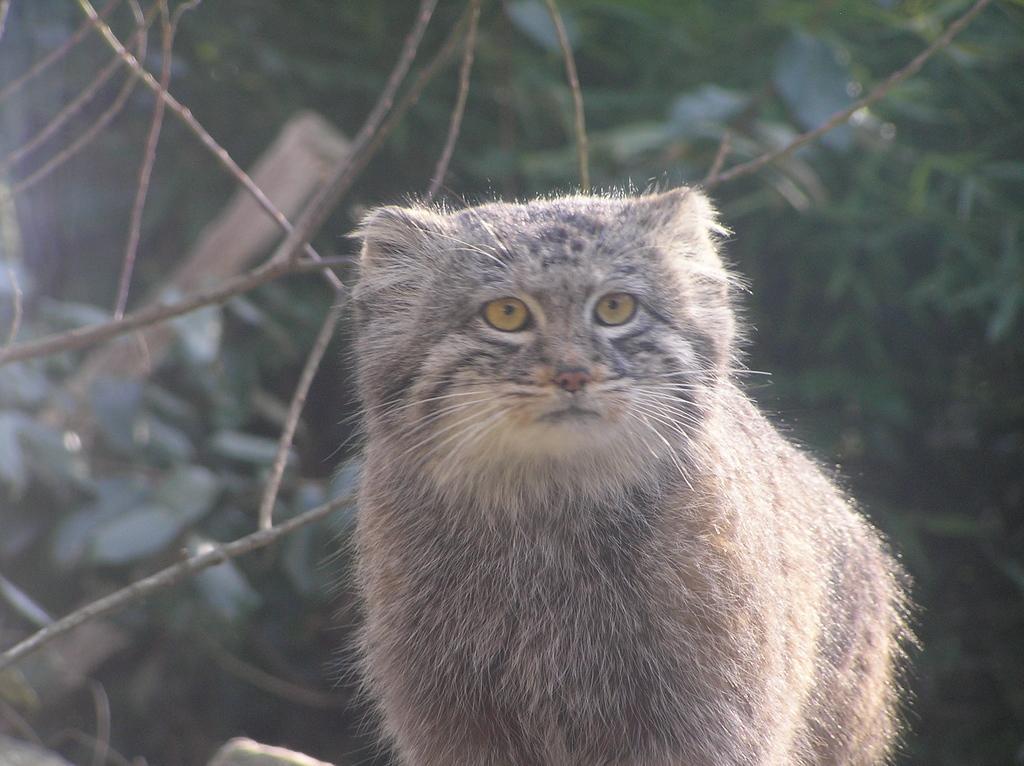Describe this image in one or two sentences. In this image we can see an animal such as a cat. And in the background, we can see the trees. 